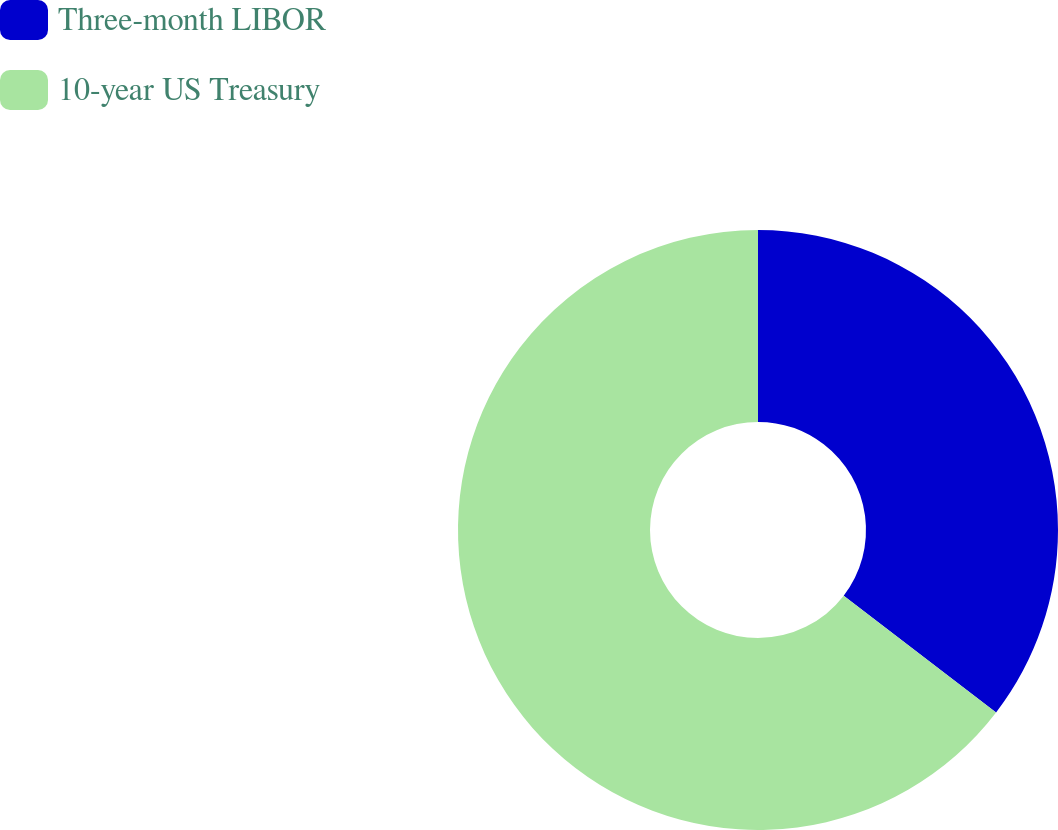Convert chart. <chart><loc_0><loc_0><loc_500><loc_500><pie_chart><fcel>Three-month LIBOR<fcel>10-year US Treasury<nl><fcel>35.41%<fcel>64.59%<nl></chart> 